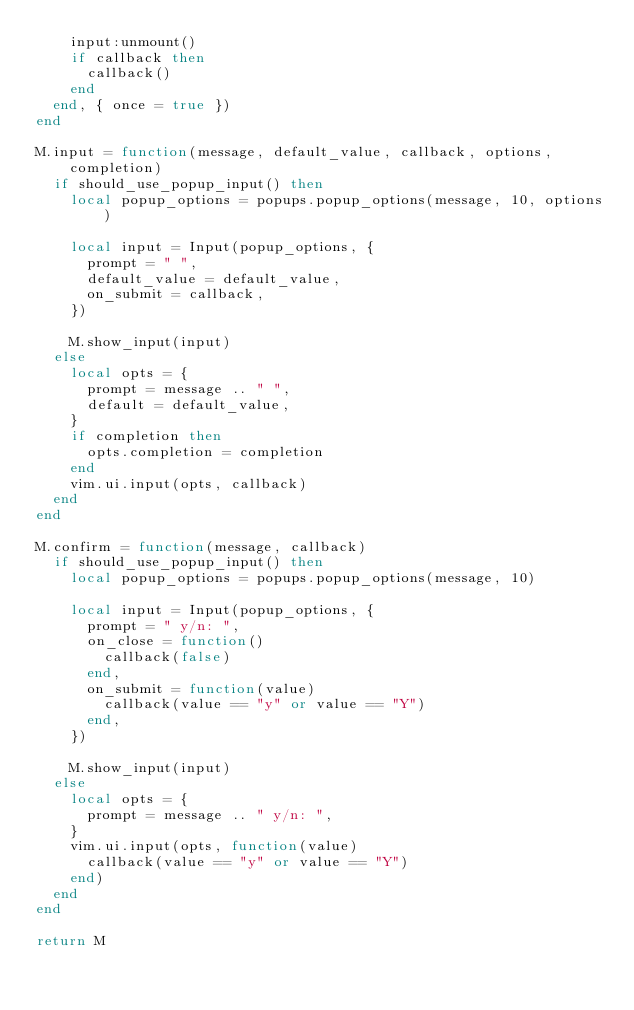Convert code to text. <code><loc_0><loc_0><loc_500><loc_500><_Lua_>    input:unmount()
    if callback then
      callback()
    end
  end, { once = true })
end

M.input = function(message, default_value, callback, options, completion)
  if should_use_popup_input() then
    local popup_options = popups.popup_options(message, 10, options)

    local input = Input(popup_options, {
      prompt = " ",
      default_value = default_value,
      on_submit = callback,
    })

    M.show_input(input)
  else
    local opts = {
      prompt = message .. " ",
      default = default_value,
    }
    if completion then
      opts.completion = completion
    end
    vim.ui.input(opts, callback)
  end
end

M.confirm = function(message, callback)
  if should_use_popup_input() then
    local popup_options = popups.popup_options(message, 10)

    local input = Input(popup_options, {
      prompt = " y/n: ",
      on_close = function()
        callback(false)
      end,
      on_submit = function(value)
        callback(value == "y" or value == "Y")
      end,
    })

    M.show_input(input)
  else
    local opts = {
      prompt = message .. " y/n: ",
    }
    vim.ui.input(opts, function(value)
      callback(value == "y" or value == "Y")
    end)
  end
end

return M
</code> 